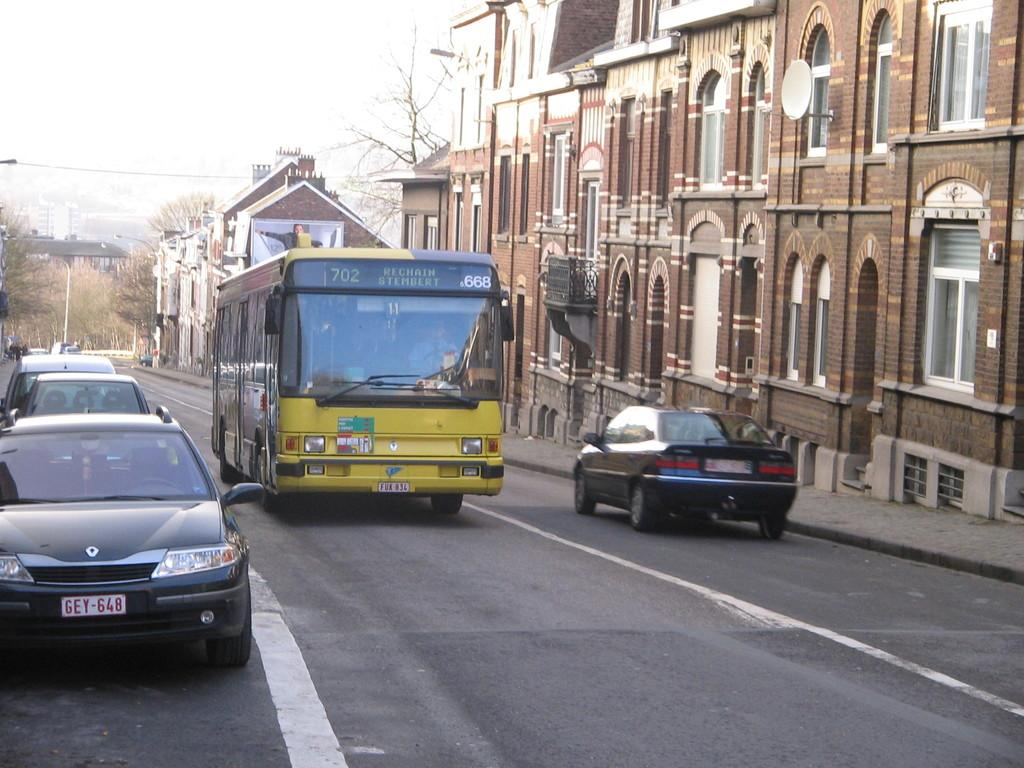<image>
Relay a brief, clear account of the picture shown. the bus number 702 going to rechain stembert 